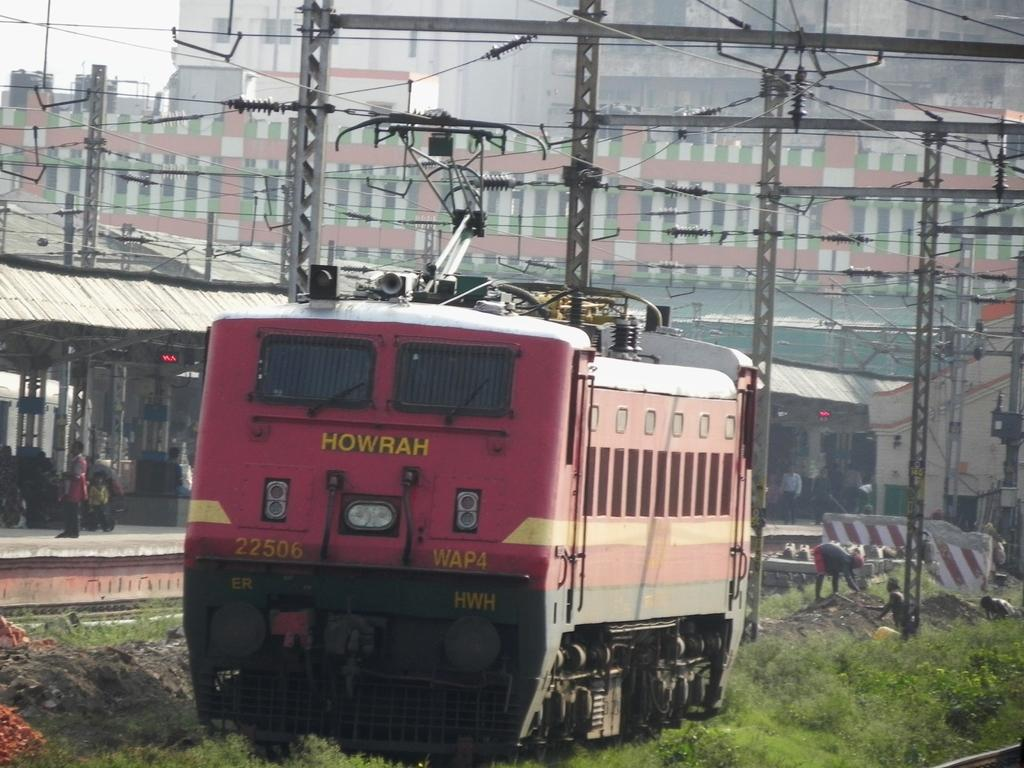What is the main subject of the image? The main subject of the image is a train. What else can be seen in the image besides the train? There is a building and poles in the image. Are there any people in the image? Yes, there is a person in the image. What type of ink is the person using to draw on the train in the image? There is no indication in the image that the person is drawing on the train or using any ink. 